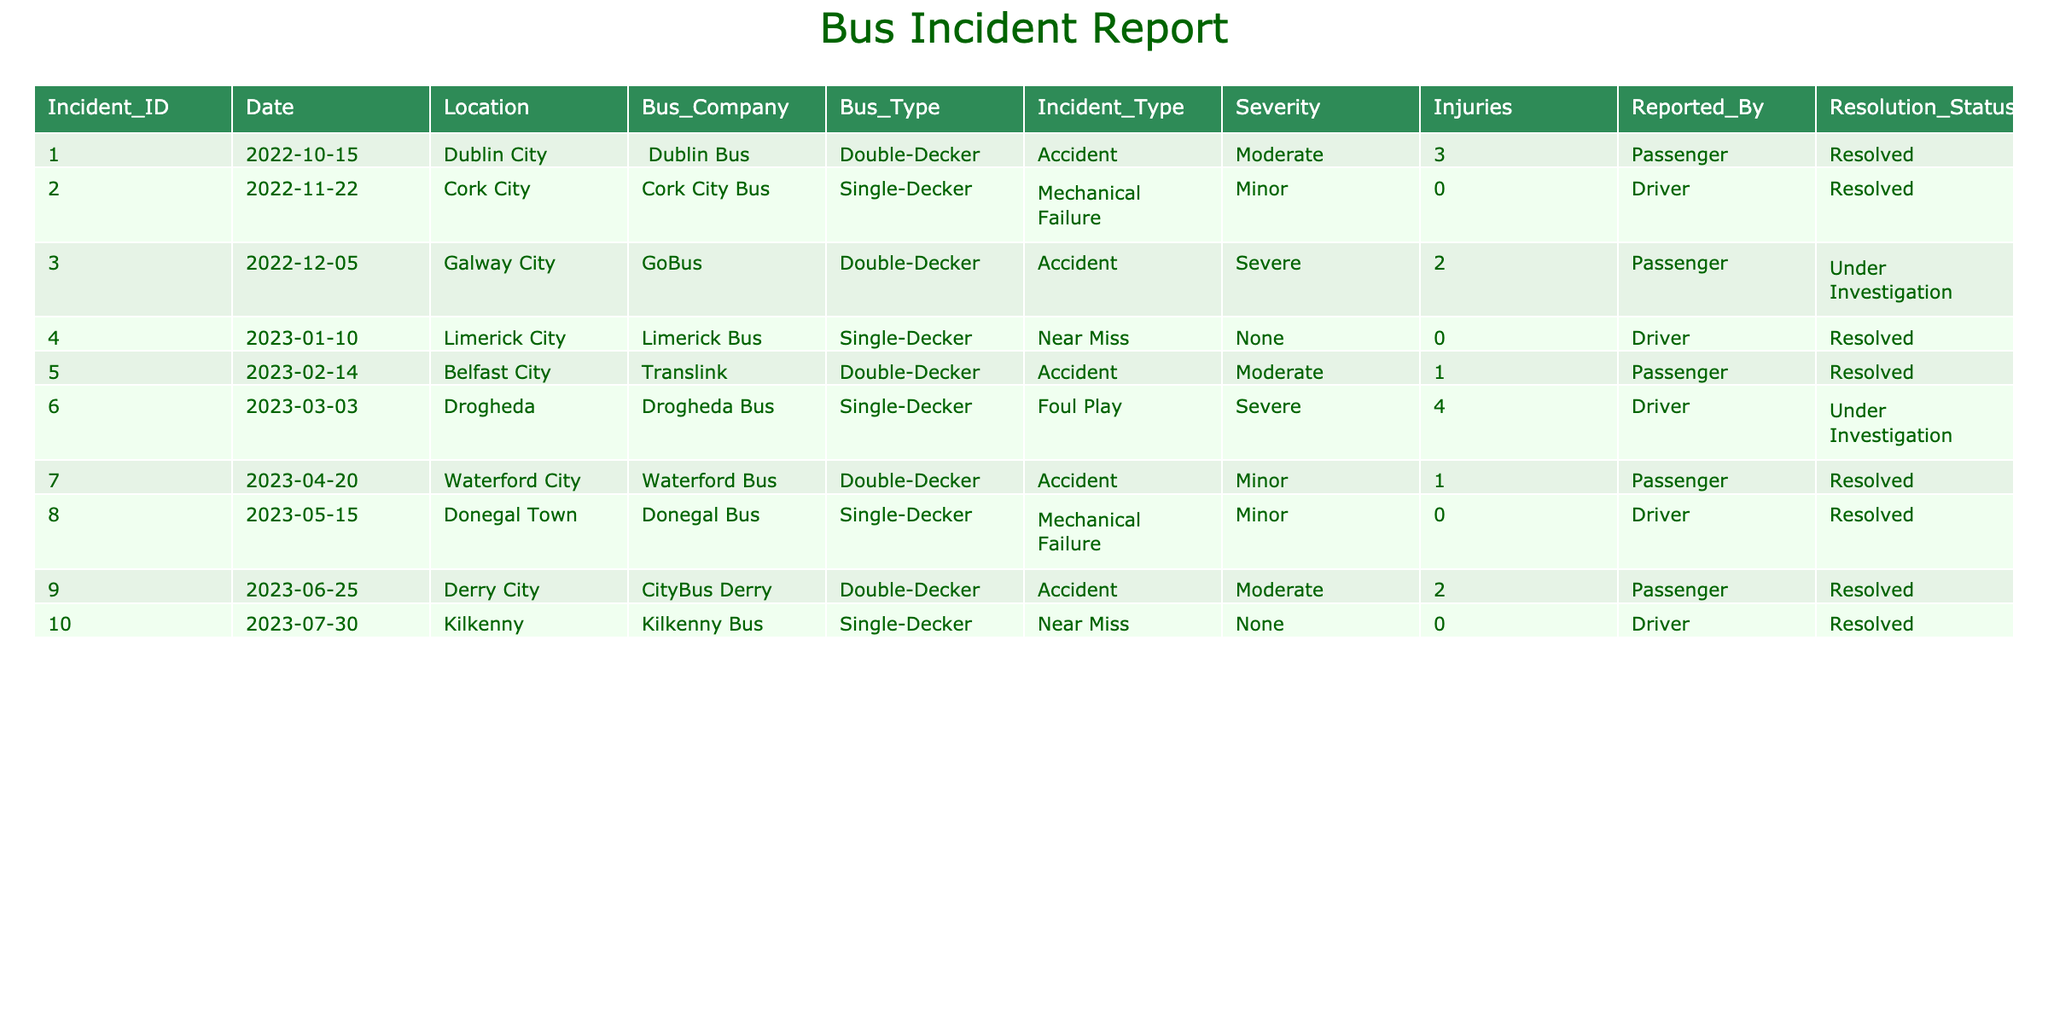What was the incident with the highest severity? The highest severity in the table is the "Severe" category, which appears in Incident_ID 003 and 006. Both incidents have a severity listed as "Severe."
Answer: Incident_ID 003 and 006 How many accidents were reported in Dublin City? Looking through the table, only one accident is reported in Dublin City, which is Incident_ID 001, categorized as an accident.
Answer: 1 What is the total number of injuries reported across all incidents? To find the total number of injuries, we sum the injuries in all incidents: (3 + 0 + 2 + 0 + 1 + 4 + 1 + 0 + 2 + 0) = 13.
Answer: 13 Were there any incidents involving “Foul Play”? Yes, there was one incident involving "Foul Play," which is Incident_ID 006.
Answer: Yes Which bus company experienced the highest number of incidents? We tally the incidents by bus company: Dublin Bus (1), Cork City Bus (1), GoBus (1), Limerick Bus (1), Translink (1), Drogheda Bus (1), Waterford Bus (1), Donegal Bus (1), CityBus Derry (1), Kilkenny Bus (1). All companies have 1 incident; therefore, no specific bus company has the highest.
Answer: None How many incidents are still under investigation? Investigating the table, there are two incidents labeled as "Under Investigation," which are Incident_ID 003 and 006.
Answer: 2 What is the ratio of resolved incidents to total incidents? There are a total of 10 incidents, with 8 labeled "Resolved." Therefore, the ratio of resolved incidents to total incidents is 8:10, simplifying to 4:5.
Answer: 4:5 Which bus type had the most severe incidents? Both severe incidents involve different bus types: Incident_ID 003 with a double-decker and Incident_ID 006 with a single-decker. Thus, there is no clear single bus type with the most severe incidents.
Answer: None How many incidents involved injuries? From the table, only the incidents with injury counts greater than zero are counted: Incident_ID 001 (3), 003 (2), 005 (1), 006 (4), and 007 (1). Adding those yields a total of 5 incidents with injuries.
Answer: 5 